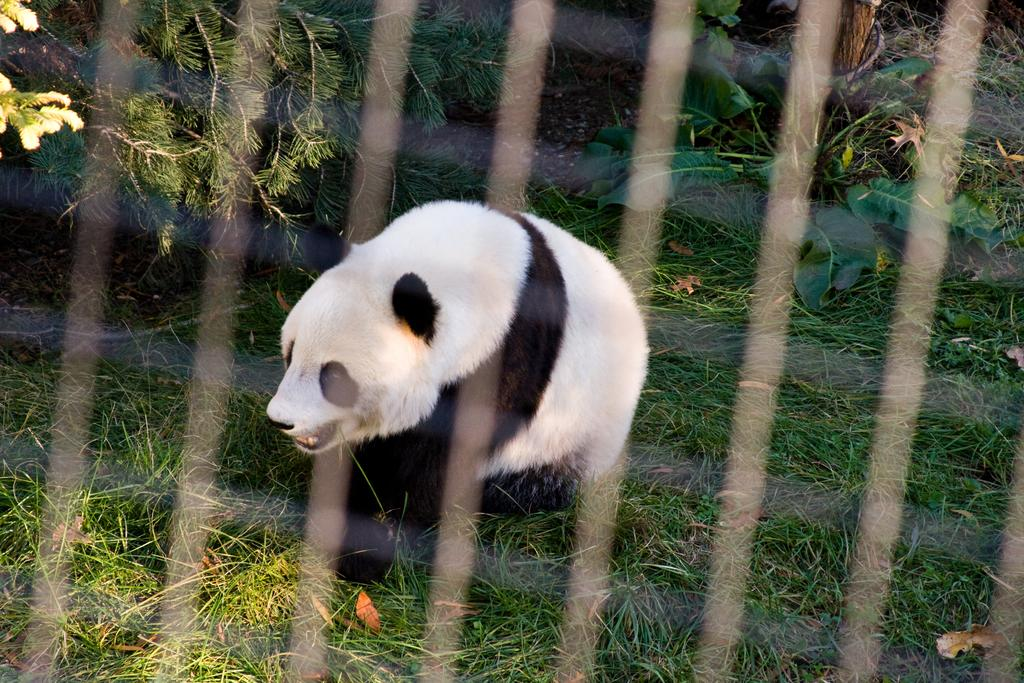What type of toy is present in the image? There is a teddy bear in the image. What type of natural environment is depicted in the image? There is grass and a tree in the image. What type of bean is being served at the feast in the image? There is no feast or bean present in the image; it features a teddy bear in a natural environment with grass and a tree. 